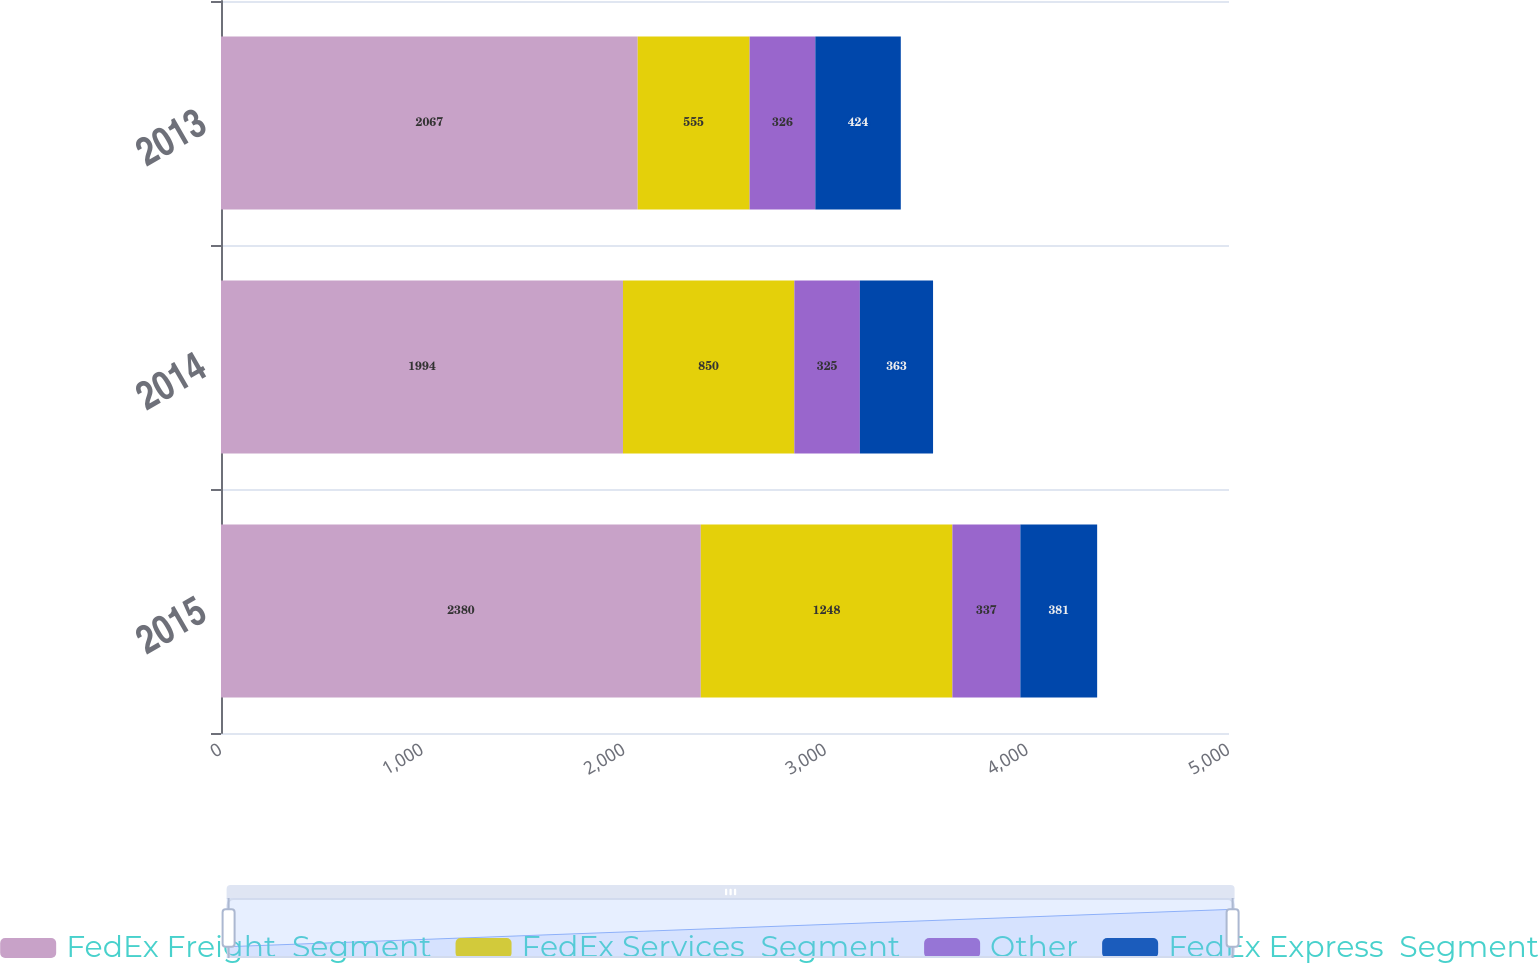Convert chart to OTSL. <chart><loc_0><loc_0><loc_500><loc_500><stacked_bar_chart><ecel><fcel>2015<fcel>2014<fcel>2013<nl><fcel>FedEx Freight  Segment<fcel>2380<fcel>1994<fcel>2067<nl><fcel>FedEx Services  Segment<fcel>1248<fcel>850<fcel>555<nl><fcel>Other<fcel>337<fcel>325<fcel>326<nl><fcel>FedEx Express  Segment<fcel>381<fcel>363<fcel>424<nl></chart> 